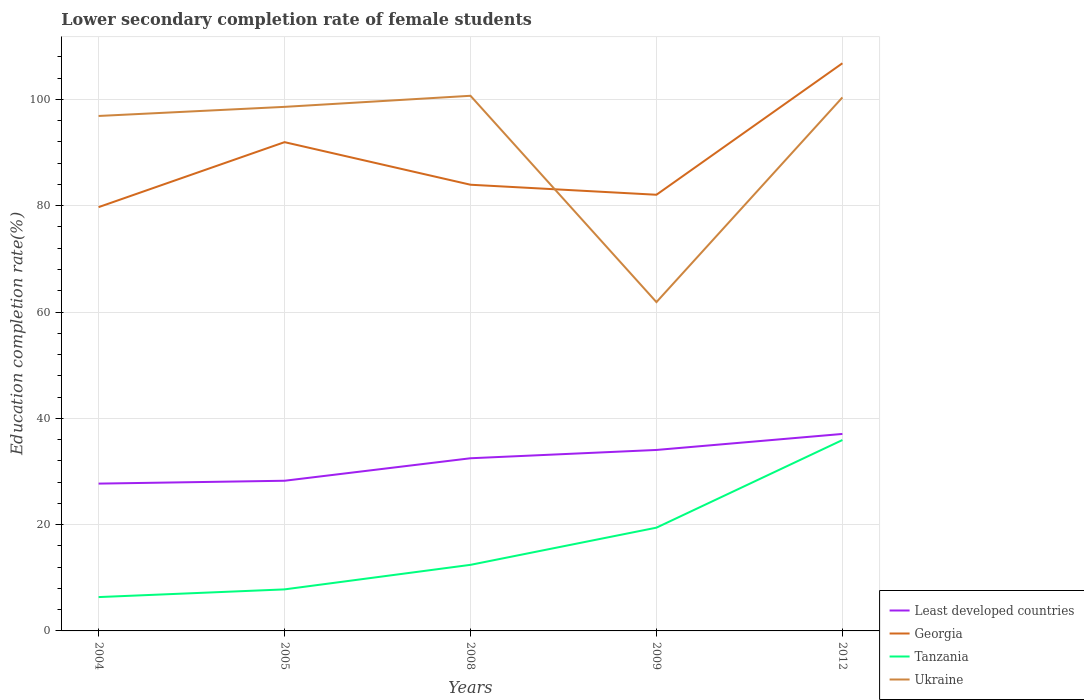Does the line corresponding to Tanzania intersect with the line corresponding to Georgia?
Provide a short and direct response. No. Is the number of lines equal to the number of legend labels?
Offer a very short reply. Yes. Across all years, what is the maximum lower secondary completion rate of female students in Least developed countries?
Make the answer very short. 27.72. In which year was the lower secondary completion rate of female students in Least developed countries maximum?
Provide a short and direct response. 2004. What is the total lower secondary completion rate of female students in Tanzania in the graph?
Give a very brief answer. -23.48. What is the difference between the highest and the second highest lower secondary completion rate of female students in Ukraine?
Keep it short and to the point. 38.82. What is the difference between the highest and the lowest lower secondary completion rate of female students in Least developed countries?
Keep it short and to the point. 3. Is the lower secondary completion rate of female students in Least developed countries strictly greater than the lower secondary completion rate of female students in Georgia over the years?
Offer a terse response. Yes. How many lines are there?
Provide a succinct answer. 4. How many legend labels are there?
Offer a very short reply. 4. What is the title of the graph?
Your response must be concise. Lower secondary completion rate of female students. Does "Albania" appear as one of the legend labels in the graph?
Keep it short and to the point. No. What is the label or title of the X-axis?
Ensure brevity in your answer.  Years. What is the label or title of the Y-axis?
Give a very brief answer. Education completion rate(%). What is the Education completion rate(%) in Least developed countries in 2004?
Ensure brevity in your answer.  27.72. What is the Education completion rate(%) in Georgia in 2004?
Give a very brief answer. 79.73. What is the Education completion rate(%) in Tanzania in 2004?
Provide a short and direct response. 6.37. What is the Education completion rate(%) of Ukraine in 2004?
Offer a terse response. 96.89. What is the Education completion rate(%) of Least developed countries in 2005?
Provide a short and direct response. 28.25. What is the Education completion rate(%) of Georgia in 2005?
Provide a short and direct response. 91.96. What is the Education completion rate(%) in Tanzania in 2005?
Keep it short and to the point. 7.81. What is the Education completion rate(%) in Ukraine in 2005?
Provide a short and direct response. 98.6. What is the Education completion rate(%) of Least developed countries in 2008?
Keep it short and to the point. 32.49. What is the Education completion rate(%) in Georgia in 2008?
Your response must be concise. 83.95. What is the Education completion rate(%) in Tanzania in 2008?
Provide a short and direct response. 12.43. What is the Education completion rate(%) in Ukraine in 2008?
Provide a short and direct response. 100.68. What is the Education completion rate(%) in Least developed countries in 2009?
Keep it short and to the point. 34.05. What is the Education completion rate(%) of Georgia in 2009?
Your answer should be very brief. 82.06. What is the Education completion rate(%) in Tanzania in 2009?
Your response must be concise. 19.43. What is the Education completion rate(%) in Ukraine in 2009?
Provide a short and direct response. 61.86. What is the Education completion rate(%) of Least developed countries in 2012?
Offer a terse response. 37.06. What is the Education completion rate(%) of Georgia in 2012?
Ensure brevity in your answer.  106.8. What is the Education completion rate(%) of Tanzania in 2012?
Give a very brief answer. 35.92. What is the Education completion rate(%) of Ukraine in 2012?
Your response must be concise. 100.37. Across all years, what is the maximum Education completion rate(%) in Least developed countries?
Make the answer very short. 37.06. Across all years, what is the maximum Education completion rate(%) in Georgia?
Keep it short and to the point. 106.8. Across all years, what is the maximum Education completion rate(%) of Tanzania?
Offer a terse response. 35.92. Across all years, what is the maximum Education completion rate(%) of Ukraine?
Offer a terse response. 100.68. Across all years, what is the minimum Education completion rate(%) in Least developed countries?
Keep it short and to the point. 27.72. Across all years, what is the minimum Education completion rate(%) of Georgia?
Give a very brief answer. 79.73. Across all years, what is the minimum Education completion rate(%) in Tanzania?
Give a very brief answer. 6.37. Across all years, what is the minimum Education completion rate(%) in Ukraine?
Your answer should be very brief. 61.86. What is the total Education completion rate(%) of Least developed countries in the graph?
Your answer should be very brief. 159.56. What is the total Education completion rate(%) of Georgia in the graph?
Provide a succinct answer. 444.51. What is the total Education completion rate(%) in Tanzania in the graph?
Your response must be concise. 81.96. What is the total Education completion rate(%) in Ukraine in the graph?
Offer a very short reply. 458.4. What is the difference between the Education completion rate(%) of Least developed countries in 2004 and that in 2005?
Provide a succinct answer. -0.54. What is the difference between the Education completion rate(%) in Georgia in 2004 and that in 2005?
Keep it short and to the point. -12.23. What is the difference between the Education completion rate(%) in Tanzania in 2004 and that in 2005?
Make the answer very short. -1.45. What is the difference between the Education completion rate(%) of Ukraine in 2004 and that in 2005?
Offer a very short reply. -1.71. What is the difference between the Education completion rate(%) of Least developed countries in 2004 and that in 2008?
Provide a succinct answer. -4.77. What is the difference between the Education completion rate(%) in Georgia in 2004 and that in 2008?
Keep it short and to the point. -4.21. What is the difference between the Education completion rate(%) of Tanzania in 2004 and that in 2008?
Your answer should be compact. -6.07. What is the difference between the Education completion rate(%) in Ukraine in 2004 and that in 2008?
Keep it short and to the point. -3.8. What is the difference between the Education completion rate(%) in Least developed countries in 2004 and that in 2009?
Make the answer very short. -6.33. What is the difference between the Education completion rate(%) of Georgia in 2004 and that in 2009?
Make the answer very short. -2.33. What is the difference between the Education completion rate(%) of Tanzania in 2004 and that in 2009?
Provide a short and direct response. -13.06. What is the difference between the Education completion rate(%) of Ukraine in 2004 and that in 2009?
Ensure brevity in your answer.  35.02. What is the difference between the Education completion rate(%) in Least developed countries in 2004 and that in 2012?
Make the answer very short. -9.34. What is the difference between the Education completion rate(%) in Georgia in 2004 and that in 2012?
Provide a succinct answer. -27.07. What is the difference between the Education completion rate(%) in Tanzania in 2004 and that in 2012?
Your answer should be compact. -29.55. What is the difference between the Education completion rate(%) of Ukraine in 2004 and that in 2012?
Your answer should be very brief. -3.49. What is the difference between the Education completion rate(%) in Least developed countries in 2005 and that in 2008?
Your answer should be very brief. -4.23. What is the difference between the Education completion rate(%) of Georgia in 2005 and that in 2008?
Your answer should be compact. 8.01. What is the difference between the Education completion rate(%) of Tanzania in 2005 and that in 2008?
Ensure brevity in your answer.  -4.62. What is the difference between the Education completion rate(%) of Ukraine in 2005 and that in 2008?
Your response must be concise. -2.08. What is the difference between the Education completion rate(%) in Least developed countries in 2005 and that in 2009?
Ensure brevity in your answer.  -5.8. What is the difference between the Education completion rate(%) of Georgia in 2005 and that in 2009?
Provide a succinct answer. 9.9. What is the difference between the Education completion rate(%) in Tanzania in 2005 and that in 2009?
Offer a very short reply. -11.61. What is the difference between the Education completion rate(%) of Ukraine in 2005 and that in 2009?
Keep it short and to the point. 36.74. What is the difference between the Education completion rate(%) of Least developed countries in 2005 and that in 2012?
Give a very brief answer. -8.81. What is the difference between the Education completion rate(%) of Georgia in 2005 and that in 2012?
Keep it short and to the point. -14.84. What is the difference between the Education completion rate(%) in Tanzania in 2005 and that in 2012?
Give a very brief answer. -28.1. What is the difference between the Education completion rate(%) of Ukraine in 2005 and that in 2012?
Ensure brevity in your answer.  -1.77. What is the difference between the Education completion rate(%) of Least developed countries in 2008 and that in 2009?
Offer a very short reply. -1.56. What is the difference between the Education completion rate(%) of Georgia in 2008 and that in 2009?
Your response must be concise. 1.89. What is the difference between the Education completion rate(%) in Tanzania in 2008 and that in 2009?
Offer a terse response. -7. What is the difference between the Education completion rate(%) in Ukraine in 2008 and that in 2009?
Offer a terse response. 38.82. What is the difference between the Education completion rate(%) of Least developed countries in 2008 and that in 2012?
Give a very brief answer. -4.58. What is the difference between the Education completion rate(%) in Georgia in 2008 and that in 2012?
Give a very brief answer. -22.85. What is the difference between the Education completion rate(%) in Tanzania in 2008 and that in 2012?
Give a very brief answer. -23.48. What is the difference between the Education completion rate(%) of Ukraine in 2008 and that in 2012?
Make the answer very short. 0.31. What is the difference between the Education completion rate(%) in Least developed countries in 2009 and that in 2012?
Your response must be concise. -3.01. What is the difference between the Education completion rate(%) in Georgia in 2009 and that in 2012?
Ensure brevity in your answer.  -24.74. What is the difference between the Education completion rate(%) in Tanzania in 2009 and that in 2012?
Your answer should be compact. -16.49. What is the difference between the Education completion rate(%) of Ukraine in 2009 and that in 2012?
Offer a terse response. -38.51. What is the difference between the Education completion rate(%) in Least developed countries in 2004 and the Education completion rate(%) in Georgia in 2005?
Give a very brief answer. -64.24. What is the difference between the Education completion rate(%) of Least developed countries in 2004 and the Education completion rate(%) of Tanzania in 2005?
Offer a very short reply. 19.9. What is the difference between the Education completion rate(%) in Least developed countries in 2004 and the Education completion rate(%) in Ukraine in 2005?
Your answer should be very brief. -70.88. What is the difference between the Education completion rate(%) of Georgia in 2004 and the Education completion rate(%) of Tanzania in 2005?
Keep it short and to the point. 71.92. What is the difference between the Education completion rate(%) in Georgia in 2004 and the Education completion rate(%) in Ukraine in 2005?
Provide a short and direct response. -18.87. What is the difference between the Education completion rate(%) of Tanzania in 2004 and the Education completion rate(%) of Ukraine in 2005?
Provide a succinct answer. -92.23. What is the difference between the Education completion rate(%) in Least developed countries in 2004 and the Education completion rate(%) in Georgia in 2008?
Provide a short and direct response. -56.23. What is the difference between the Education completion rate(%) in Least developed countries in 2004 and the Education completion rate(%) in Tanzania in 2008?
Keep it short and to the point. 15.28. What is the difference between the Education completion rate(%) of Least developed countries in 2004 and the Education completion rate(%) of Ukraine in 2008?
Provide a succinct answer. -72.97. What is the difference between the Education completion rate(%) of Georgia in 2004 and the Education completion rate(%) of Tanzania in 2008?
Your answer should be very brief. 67.3. What is the difference between the Education completion rate(%) in Georgia in 2004 and the Education completion rate(%) in Ukraine in 2008?
Your answer should be very brief. -20.95. What is the difference between the Education completion rate(%) of Tanzania in 2004 and the Education completion rate(%) of Ukraine in 2008?
Give a very brief answer. -94.32. What is the difference between the Education completion rate(%) of Least developed countries in 2004 and the Education completion rate(%) of Georgia in 2009?
Keep it short and to the point. -54.35. What is the difference between the Education completion rate(%) of Least developed countries in 2004 and the Education completion rate(%) of Tanzania in 2009?
Provide a succinct answer. 8.29. What is the difference between the Education completion rate(%) of Least developed countries in 2004 and the Education completion rate(%) of Ukraine in 2009?
Keep it short and to the point. -34.15. What is the difference between the Education completion rate(%) in Georgia in 2004 and the Education completion rate(%) in Tanzania in 2009?
Provide a short and direct response. 60.31. What is the difference between the Education completion rate(%) in Georgia in 2004 and the Education completion rate(%) in Ukraine in 2009?
Offer a very short reply. 17.87. What is the difference between the Education completion rate(%) of Tanzania in 2004 and the Education completion rate(%) of Ukraine in 2009?
Offer a very short reply. -55.5. What is the difference between the Education completion rate(%) of Least developed countries in 2004 and the Education completion rate(%) of Georgia in 2012?
Offer a very short reply. -79.08. What is the difference between the Education completion rate(%) in Least developed countries in 2004 and the Education completion rate(%) in Tanzania in 2012?
Your answer should be compact. -8.2. What is the difference between the Education completion rate(%) in Least developed countries in 2004 and the Education completion rate(%) in Ukraine in 2012?
Your response must be concise. -72.65. What is the difference between the Education completion rate(%) in Georgia in 2004 and the Education completion rate(%) in Tanzania in 2012?
Make the answer very short. 43.82. What is the difference between the Education completion rate(%) of Georgia in 2004 and the Education completion rate(%) of Ukraine in 2012?
Offer a terse response. -20.64. What is the difference between the Education completion rate(%) of Tanzania in 2004 and the Education completion rate(%) of Ukraine in 2012?
Ensure brevity in your answer.  -94.01. What is the difference between the Education completion rate(%) in Least developed countries in 2005 and the Education completion rate(%) in Georgia in 2008?
Provide a short and direct response. -55.69. What is the difference between the Education completion rate(%) of Least developed countries in 2005 and the Education completion rate(%) of Tanzania in 2008?
Keep it short and to the point. 15.82. What is the difference between the Education completion rate(%) in Least developed countries in 2005 and the Education completion rate(%) in Ukraine in 2008?
Make the answer very short. -72.43. What is the difference between the Education completion rate(%) in Georgia in 2005 and the Education completion rate(%) in Tanzania in 2008?
Your answer should be very brief. 79.53. What is the difference between the Education completion rate(%) in Georgia in 2005 and the Education completion rate(%) in Ukraine in 2008?
Your answer should be very brief. -8.72. What is the difference between the Education completion rate(%) of Tanzania in 2005 and the Education completion rate(%) of Ukraine in 2008?
Give a very brief answer. -92.87. What is the difference between the Education completion rate(%) in Least developed countries in 2005 and the Education completion rate(%) in Georgia in 2009?
Your answer should be very brief. -53.81. What is the difference between the Education completion rate(%) of Least developed countries in 2005 and the Education completion rate(%) of Tanzania in 2009?
Your answer should be very brief. 8.83. What is the difference between the Education completion rate(%) of Least developed countries in 2005 and the Education completion rate(%) of Ukraine in 2009?
Offer a very short reply. -33.61. What is the difference between the Education completion rate(%) of Georgia in 2005 and the Education completion rate(%) of Tanzania in 2009?
Give a very brief answer. 72.53. What is the difference between the Education completion rate(%) in Georgia in 2005 and the Education completion rate(%) in Ukraine in 2009?
Offer a terse response. 30.1. What is the difference between the Education completion rate(%) of Tanzania in 2005 and the Education completion rate(%) of Ukraine in 2009?
Keep it short and to the point. -54.05. What is the difference between the Education completion rate(%) in Least developed countries in 2005 and the Education completion rate(%) in Georgia in 2012?
Offer a very short reply. -78.55. What is the difference between the Education completion rate(%) in Least developed countries in 2005 and the Education completion rate(%) in Tanzania in 2012?
Offer a very short reply. -7.66. What is the difference between the Education completion rate(%) of Least developed countries in 2005 and the Education completion rate(%) of Ukraine in 2012?
Provide a succinct answer. -72.12. What is the difference between the Education completion rate(%) of Georgia in 2005 and the Education completion rate(%) of Tanzania in 2012?
Provide a short and direct response. 56.05. What is the difference between the Education completion rate(%) of Georgia in 2005 and the Education completion rate(%) of Ukraine in 2012?
Offer a terse response. -8.41. What is the difference between the Education completion rate(%) of Tanzania in 2005 and the Education completion rate(%) of Ukraine in 2012?
Make the answer very short. -92.56. What is the difference between the Education completion rate(%) in Least developed countries in 2008 and the Education completion rate(%) in Georgia in 2009?
Offer a very short reply. -49.58. What is the difference between the Education completion rate(%) of Least developed countries in 2008 and the Education completion rate(%) of Tanzania in 2009?
Provide a succinct answer. 13.06. What is the difference between the Education completion rate(%) of Least developed countries in 2008 and the Education completion rate(%) of Ukraine in 2009?
Offer a very short reply. -29.38. What is the difference between the Education completion rate(%) of Georgia in 2008 and the Education completion rate(%) of Tanzania in 2009?
Give a very brief answer. 64.52. What is the difference between the Education completion rate(%) in Georgia in 2008 and the Education completion rate(%) in Ukraine in 2009?
Your answer should be compact. 22.08. What is the difference between the Education completion rate(%) of Tanzania in 2008 and the Education completion rate(%) of Ukraine in 2009?
Your answer should be compact. -49.43. What is the difference between the Education completion rate(%) in Least developed countries in 2008 and the Education completion rate(%) in Georgia in 2012?
Give a very brief answer. -74.32. What is the difference between the Education completion rate(%) of Least developed countries in 2008 and the Education completion rate(%) of Tanzania in 2012?
Give a very brief answer. -3.43. What is the difference between the Education completion rate(%) in Least developed countries in 2008 and the Education completion rate(%) in Ukraine in 2012?
Keep it short and to the point. -67.89. What is the difference between the Education completion rate(%) of Georgia in 2008 and the Education completion rate(%) of Tanzania in 2012?
Offer a terse response. 48.03. What is the difference between the Education completion rate(%) in Georgia in 2008 and the Education completion rate(%) in Ukraine in 2012?
Provide a succinct answer. -16.42. What is the difference between the Education completion rate(%) of Tanzania in 2008 and the Education completion rate(%) of Ukraine in 2012?
Give a very brief answer. -87.94. What is the difference between the Education completion rate(%) of Least developed countries in 2009 and the Education completion rate(%) of Georgia in 2012?
Ensure brevity in your answer.  -72.75. What is the difference between the Education completion rate(%) in Least developed countries in 2009 and the Education completion rate(%) in Tanzania in 2012?
Give a very brief answer. -1.87. What is the difference between the Education completion rate(%) of Least developed countries in 2009 and the Education completion rate(%) of Ukraine in 2012?
Your response must be concise. -66.32. What is the difference between the Education completion rate(%) in Georgia in 2009 and the Education completion rate(%) in Tanzania in 2012?
Offer a terse response. 46.15. What is the difference between the Education completion rate(%) in Georgia in 2009 and the Education completion rate(%) in Ukraine in 2012?
Your response must be concise. -18.31. What is the difference between the Education completion rate(%) of Tanzania in 2009 and the Education completion rate(%) of Ukraine in 2012?
Ensure brevity in your answer.  -80.94. What is the average Education completion rate(%) of Least developed countries per year?
Give a very brief answer. 31.91. What is the average Education completion rate(%) of Georgia per year?
Ensure brevity in your answer.  88.9. What is the average Education completion rate(%) in Tanzania per year?
Give a very brief answer. 16.39. What is the average Education completion rate(%) in Ukraine per year?
Your answer should be very brief. 91.68. In the year 2004, what is the difference between the Education completion rate(%) of Least developed countries and Education completion rate(%) of Georgia?
Your answer should be compact. -52.02. In the year 2004, what is the difference between the Education completion rate(%) in Least developed countries and Education completion rate(%) in Tanzania?
Give a very brief answer. 21.35. In the year 2004, what is the difference between the Education completion rate(%) of Least developed countries and Education completion rate(%) of Ukraine?
Keep it short and to the point. -69.17. In the year 2004, what is the difference between the Education completion rate(%) of Georgia and Education completion rate(%) of Tanzania?
Your response must be concise. 73.37. In the year 2004, what is the difference between the Education completion rate(%) in Georgia and Education completion rate(%) in Ukraine?
Offer a terse response. -17.15. In the year 2004, what is the difference between the Education completion rate(%) in Tanzania and Education completion rate(%) in Ukraine?
Offer a very short reply. -90.52. In the year 2005, what is the difference between the Education completion rate(%) of Least developed countries and Education completion rate(%) of Georgia?
Make the answer very short. -63.71. In the year 2005, what is the difference between the Education completion rate(%) in Least developed countries and Education completion rate(%) in Tanzania?
Offer a very short reply. 20.44. In the year 2005, what is the difference between the Education completion rate(%) of Least developed countries and Education completion rate(%) of Ukraine?
Provide a short and direct response. -70.35. In the year 2005, what is the difference between the Education completion rate(%) in Georgia and Education completion rate(%) in Tanzania?
Provide a short and direct response. 84.15. In the year 2005, what is the difference between the Education completion rate(%) in Georgia and Education completion rate(%) in Ukraine?
Provide a short and direct response. -6.64. In the year 2005, what is the difference between the Education completion rate(%) of Tanzania and Education completion rate(%) of Ukraine?
Offer a very short reply. -90.78. In the year 2008, what is the difference between the Education completion rate(%) of Least developed countries and Education completion rate(%) of Georgia?
Ensure brevity in your answer.  -51.46. In the year 2008, what is the difference between the Education completion rate(%) of Least developed countries and Education completion rate(%) of Tanzania?
Make the answer very short. 20.05. In the year 2008, what is the difference between the Education completion rate(%) in Least developed countries and Education completion rate(%) in Ukraine?
Ensure brevity in your answer.  -68.2. In the year 2008, what is the difference between the Education completion rate(%) in Georgia and Education completion rate(%) in Tanzania?
Your answer should be compact. 71.52. In the year 2008, what is the difference between the Education completion rate(%) of Georgia and Education completion rate(%) of Ukraine?
Your answer should be compact. -16.74. In the year 2008, what is the difference between the Education completion rate(%) of Tanzania and Education completion rate(%) of Ukraine?
Offer a terse response. -88.25. In the year 2009, what is the difference between the Education completion rate(%) in Least developed countries and Education completion rate(%) in Georgia?
Ensure brevity in your answer.  -48.01. In the year 2009, what is the difference between the Education completion rate(%) in Least developed countries and Education completion rate(%) in Tanzania?
Your answer should be very brief. 14.62. In the year 2009, what is the difference between the Education completion rate(%) of Least developed countries and Education completion rate(%) of Ukraine?
Keep it short and to the point. -27.82. In the year 2009, what is the difference between the Education completion rate(%) in Georgia and Education completion rate(%) in Tanzania?
Provide a succinct answer. 62.63. In the year 2009, what is the difference between the Education completion rate(%) of Georgia and Education completion rate(%) of Ukraine?
Keep it short and to the point. 20.2. In the year 2009, what is the difference between the Education completion rate(%) of Tanzania and Education completion rate(%) of Ukraine?
Your answer should be very brief. -42.44. In the year 2012, what is the difference between the Education completion rate(%) in Least developed countries and Education completion rate(%) in Georgia?
Provide a succinct answer. -69.74. In the year 2012, what is the difference between the Education completion rate(%) of Least developed countries and Education completion rate(%) of Tanzania?
Your answer should be very brief. 1.15. In the year 2012, what is the difference between the Education completion rate(%) in Least developed countries and Education completion rate(%) in Ukraine?
Offer a terse response. -63.31. In the year 2012, what is the difference between the Education completion rate(%) in Georgia and Education completion rate(%) in Tanzania?
Keep it short and to the point. 70.89. In the year 2012, what is the difference between the Education completion rate(%) in Georgia and Education completion rate(%) in Ukraine?
Provide a short and direct response. 6.43. In the year 2012, what is the difference between the Education completion rate(%) of Tanzania and Education completion rate(%) of Ukraine?
Provide a succinct answer. -64.46. What is the ratio of the Education completion rate(%) of Georgia in 2004 to that in 2005?
Keep it short and to the point. 0.87. What is the ratio of the Education completion rate(%) of Tanzania in 2004 to that in 2005?
Give a very brief answer. 0.81. What is the ratio of the Education completion rate(%) of Ukraine in 2004 to that in 2005?
Ensure brevity in your answer.  0.98. What is the ratio of the Education completion rate(%) in Least developed countries in 2004 to that in 2008?
Your response must be concise. 0.85. What is the ratio of the Education completion rate(%) in Georgia in 2004 to that in 2008?
Give a very brief answer. 0.95. What is the ratio of the Education completion rate(%) in Tanzania in 2004 to that in 2008?
Provide a short and direct response. 0.51. What is the ratio of the Education completion rate(%) of Ukraine in 2004 to that in 2008?
Your response must be concise. 0.96. What is the ratio of the Education completion rate(%) in Least developed countries in 2004 to that in 2009?
Offer a terse response. 0.81. What is the ratio of the Education completion rate(%) of Georgia in 2004 to that in 2009?
Keep it short and to the point. 0.97. What is the ratio of the Education completion rate(%) of Tanzania in 2004 to that in 2009?
Provide a short and direct response. 0.33. What is the ratio of the Education completion rate(%) in Ukraine in 2004 to that in 2009?
Provide a succinct answer. 1.57. What is the ratio of the Education completion rate(%) in Least developed countries in 2004 to that in 2012?
Offer a very short reply. 0.75. What is the ratio of the Education completion rate(%) in Georgia in 2004 to that in 2012?
Provide a short and direct response. 0.75. What is the ratio of the Education completion rate(%) of Tanzania in 2004 to that in 2012?
Provide a succinct answer. 0.18. What is the ratio of the Education completion rate(%) of Ukraine in 2004 to that in 2012?
Your answer should be very brief. 0.97. What is the ratio of the Education completion rate(%) of Least developed countries in 2005 to that in 2008?
Keep it short and to the point. 0.87. What is the ratio of the Education completion rate(%) in Georgia in 2005 to that in 2008?
Offer a terse response. 1.1. What is the ratio of the Education completion rate(%) in Tanzania in 2005 to that in 2008?
Ensure brevity in your answer.  0.63. What is the ratio of the Education completion rate(%) of Ukraine in 2005 to that in 2008?
Provide a short and direct response. 0.98. What is the ratio of the Education completion rate(%) of Least developed countries in 2005 to that in 2009?
Your answer should be very brief. 0.83. What is the ratio of the Education completion rate(%) in Georgia in 2005 to that in 2009?
Ensure brevity in your answer.  1.12. What is the ratio of the Education completion rate(%) of Tanzania in 2005 to that in 2009?
Your answer should be compact. 0.4. What is the ratio of the Education completion rate(%) in Ukraine in 2005 to that in 2009?
Your response must be concise. 1.59. What is the ratio of the Education completion rate(%) in Least developed countries in 2005 to that in 2012?
Your answer should be very brief. 0.76. What is the ratio of the Education completion rate(%) of Georgia in 2005 to that in 2012?
Provide a short and direct response. 0.86. What is the ratio of the Education completion rate(%) in Tanzania in 2005 to that in 2012?
Provide a succinct answer. 0.22. What is the ratio of the Education completion rate(%) of Ukraine in 2005 to that in 2012?
Keep it short and to the point. 0.98. What is the ratio of the Education completion rate(%) of Least developed countries in 2008 to that in 2009?
Keep it short and to the point. 0.95. What is the ratio of the Education completion rate(%) of Tanzania in 2008 to that in 2009?
Your answer should be compact. 0.64. What is the ratio of the Education completion rate(%) in Ukraine in 2008 to that in 2009?
Offer a very short reply. 1.63. What is the ratio of the Education completion rate(%) in Least developed countries in 2008 to that in 2012?
Make the answer very short. 0.88. What is the ratio of the Education completion rate(%) of Georgia in 2008 to that in 2012?
Give a very brief answer. 0.79. What is the ratio of the Education completion rate(%) of Tanzania in 2008 to that in 2012?
Your response must be concise. 0.35. What is the ratio of the Education completion rate(%) of Ukraine in 2008 to that in 2012?
Offer a very short reply. 1. What is the ratio of the Education completion rate(%) in Least developed countries in 2009 to that in 2012?
Ensure brevity in your answer.  0.92. What is the ratio of the Education completion rate(%) of Georgia in 2009 to that in 2012?
Give a very brief answer. 0.77. What is the ratio of the Education completion rate(%) of Tanzania in 2009 to that in 2012?
Keep it short and to the point. 0.54. What is the ratio of the Education completion rate(%) in Ukraine in 2009 to that in 2012?
Your response must be concise. 0.62. What is the difference between the highest and the second highest Education completion rate(%) of Least developed countries?
Ensure brevity in your answer.  3.01. What is the difference between the highest and the second highest Education completion rate(%) in Georgia?
Your response must be concise. 14.84. What is the difference between the highest and the second highest Education completion rate(%) of Tanzania?
Ensure brevity in your answer.  16.49. What is the difference between the highest and the second highest Education completion rate(%) in Ukraine?
Your answer should be compact. 0.31. What is the difference between the highest and the lowest Education completion rate(%) in Least developed countries?
Keep it short and to the point. 9.34. What is the difference between the highest and the lowest Education completion rate(%) in Georgia?
Your response must be concise. 27.07. What is the difference between the highest and the lowest Education completion rate(%) of Tanzania?
Give a very brief answer. 29.55. What is the difference between the highest and the lowest Education completion rate(%) of Ukraine?
Your answer should be compact. 38.82. 